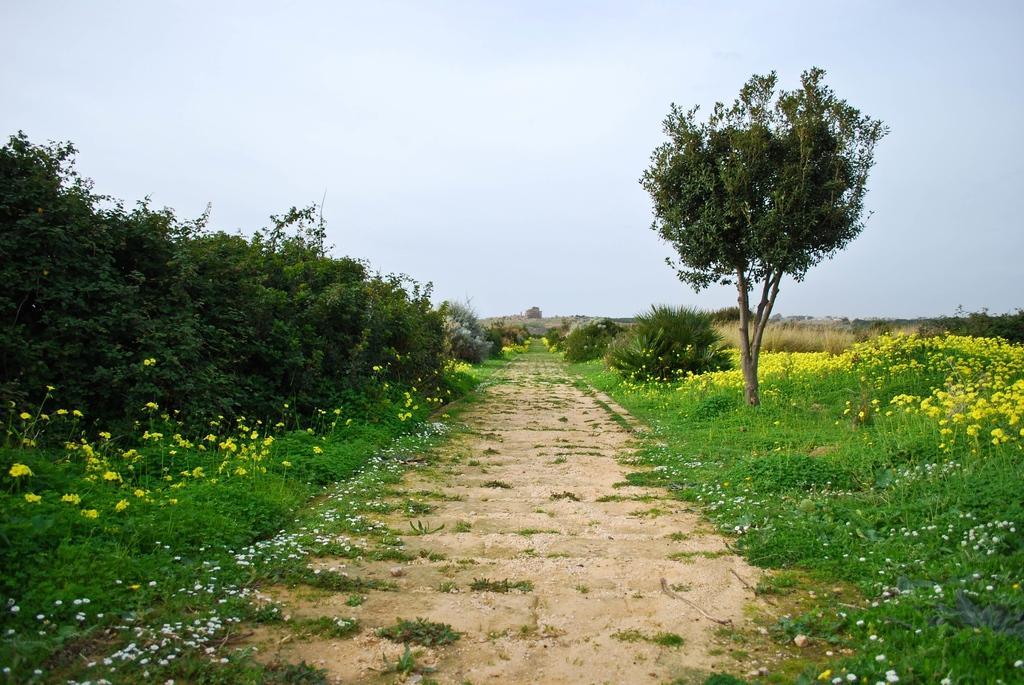Can you describe this image briefly? In this image we can see flowers, near that we can see the grass, some plants, trees, after that we can see stones, at the top we can see the sky. 